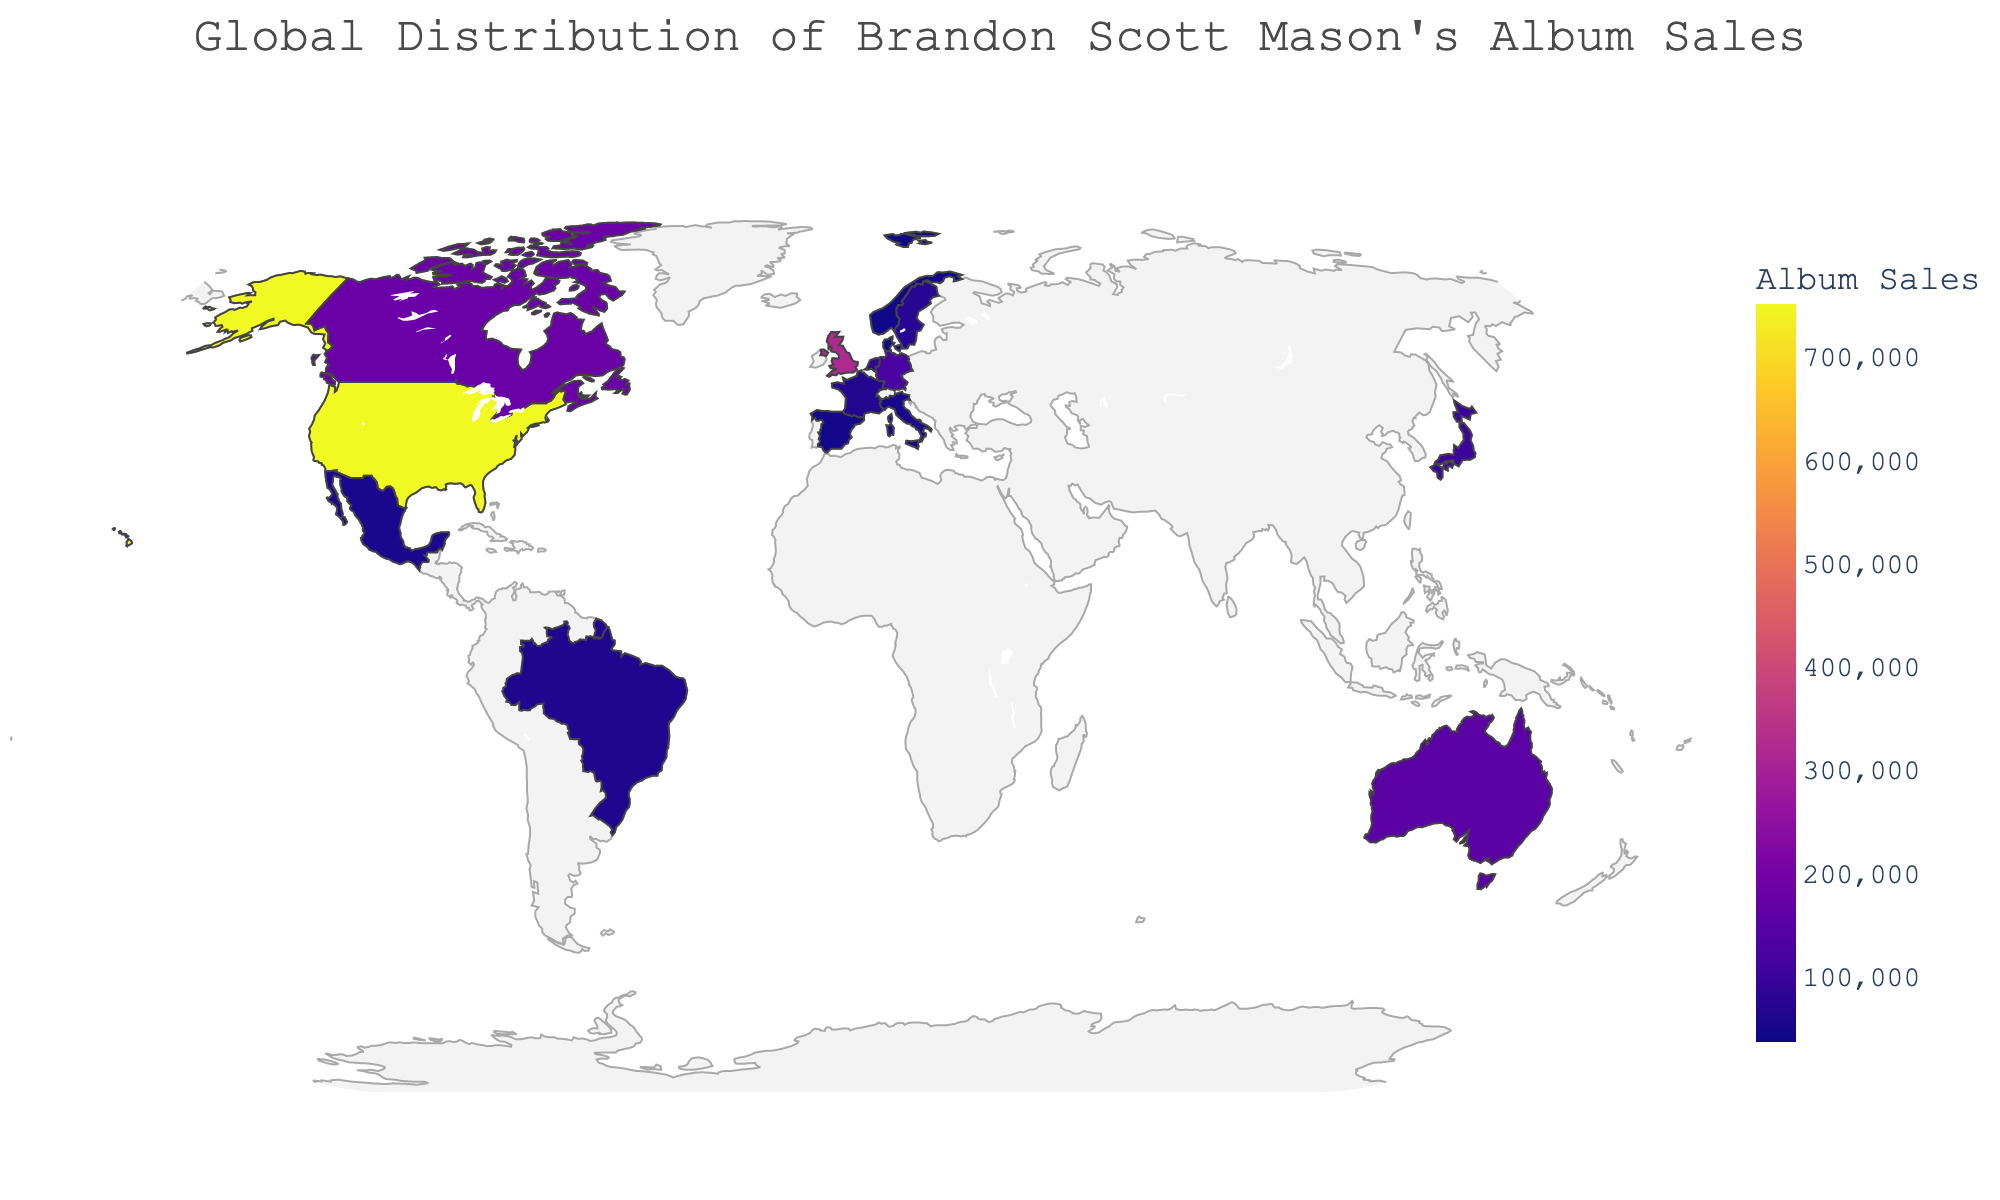Which country has the highest album sales for Brandon Scott Mason? The figure shows album sales by country, and the country with the highest value is the United States.
Answer: United States What's the total number of album sales in the United Kingdom and Canada combined? The United Kingdom has 320,000 sales, and Canada has 180,000 sales. Adding these together: 320,000 + 180,000 = 500,000
Answer: 500,000 Which countries have album sales greater than 100,000? Looking at the figure, the countries with sales greater than 100,000 are the United States, United Kingdom, Canada, Australia, and Germany.
Answer: United States, United Kingdom, Canada, Australia, Germany What is the lowest album sales value shown on the map? From the figure, the lowest album sales value is for Denmark, which is 35,000.
Answer: 35,000 How do album sales in Australia compare to those in Germany? Australia has 150,000 album sales, and Germany has 120,000 album sales, so Australia has more sales than Germany.
Answer: Australia has more What's the sum of album sales for all the countries in Europe? The countries in Europe are the United Kingdom (320,000), Germany (120,000), Netherlands (85,000), Sweden (70,000), France (65,000), Italy (50,000), Spain (45,000), Norway (40,000), and Denmark (35,000). Adding them up: 320,000 + 120,000 + 85,000 + 70,000 + 65,000 + 50,000 + 45,000 + 40,000 + 35,000 = 830,000.
Answer: 830,000 Which continent appears to have the most concentrated album sales presence for Brandon Scott Mason? By observing the countries with the highest album sales, which include the United States, United Kingdom, and Canada, it seems that North America has a more concentrated presence due to the high sales figures in the United States and Canada.
Answer: North America Which countries have album sales that fall between 50,000 and 100,000? The figure shows that Japan (100,000), Netherlands (85,000), Sweden (70,000), France (65,000), Brazil (60,000), and Mexico (55,000) fall into this range.
Answer: Japan, Netherlands, Sweden, France, Brazil, Mexico 